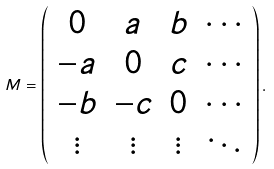Convert formula to latex. <formula><loc_0><loc_0><loc_500><loc_500>M = \left ( \begin{array} { c c c c } 0 & a & b & \cdots \\ - a & 0 & c & \cdots \\ - b & - c & 0 & \cdots \\ \vdots & \vdots & \vdots & \ddots \end{array} \right ) .</formula> 